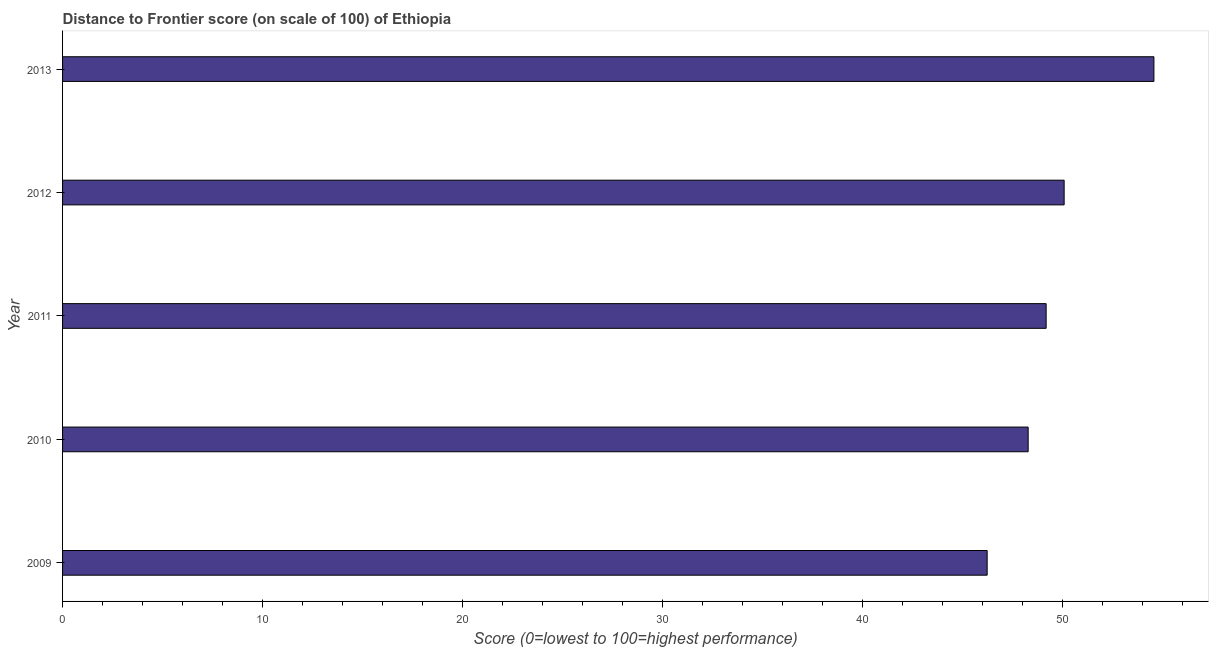Does the graph contain any zero values?
Provide a succinct answer. No. What is the title of the graph?
Your answer should be very brief. Distance to Frontier score (on scale of 100) of Ethiopia. What is the label or title of the X-axis?
Make the answer very short. Score (0=lowest to 100=highest performance). What is the label or title of the Y-axis?
Provide a succinct answer. Year. What is the distance to frontier score in 2012?
Provide a succinct answer. 50.09. Across all years, what is the maximum distance to frontier score?
Your response must be concise. 54.58. Across all years, what is the minimum distance to frontier score?
Ensure brevity in your answer.  46.24. What is the sum of the distance to frontier score?
Keep it short and to the point. 248.39. What is the difference between the distance to frontier score in 2009 and 2012?
Make the answer very short. -3.85. What is the average distance to frontier score per year?
Your answer should be very brief. 49.68. What is the median distance to frontier score?
Your response must be concise. 49.19. What is the ratio of the distance to frontier score in 2011 to that in 2013?
Your answer should be compact. 0.9. Is the difference between the distance to frontier score in 2010 and 2012 greater than the difference between any two years?
Your answer should be very brief. No. What is the difference between the highest and the second highest distance to frontier score?
Your answer should be very brief. 4.49. What is the difference between the highest and the lowest distance to frontier score?
Ensure brevity in your answer.  8.34. In how many years, is the distance to frontier score greater than the average distance to frontier score taken over all years?
Keep it short and to the point. 2. How many bars are there?
Offer a terse response. 5. Are the values on the major ticks of X-axis written in scientific E-notation?
Your answer should be very brief. No. What is the Score (0=lowest to 100=highest performance) of 2009?
Your answer should be very brief. 46.24. What is the Score (0=lowest to 100=highest performance) of 2010?
Offer a terse response. 48.29. What is the Score (0=lowest to 100=highest performance) in 2011?
Offer a terse response. 49.19. What is the Score (0=lowest to 100=highest performance) of 2012?
Provide a succinct answer. 50.09. What is the Score (0=lowest to 100=highest performance) in 2013?
Offer a very short reply. 54.58. What is the difference between the Score (0=lowest to 100=highest performance) in 2009 and 2010?
Provide a short and direct response. -2.05. What is the difference between the Score (0=lowest to 100=highest performance) in 2009 and 2011?
Offer a very short reply. -2.95. What is the difference between the Score (0=lowest to 100=highest performance) in 2009 and 2012?
Your response must be concise. -3.85. What is the difference between the Score (0=lowest to 100=highest performance) in 2009 and 2013?
Give a very brief answer. -8.34. What is the difference between the Score (0=lowest to 100=highest performance) in 2010 and 2011?
Your response must be concise. -0.9. What is the difference between the Score (0=lowest to 100=highest performance) in 2010 and 2012?
Your response must be concise. -1.8. What is the difference between the Score (0=lowest to 100=highest performance) in 2010 and 2013?
Your answer should be very brief. -6.29. What is the difference between the Score (0=lowest to 100=highest performance) in 2011 and 2013?
Make the answer very short. -5.39. What is the difference between the Score (0=lowest to 100=highest performance) in 2012 and 2013?
Ensure brevity in your answer.  -4.49. What is the ratio of the Score (0=lowest to 100=highest performance) in 2009 to that in 2010?
Your response must be concise. 0.96. What is the ratio of the Score (0=lowest to 100=highest performance) in 2009 to that in 2012?
Your response must be concise. 0.92. What is the ratio of the Score (0=lowest to 100=highest performance) in 2009 to that in 2013?
Ensure brevity in your answer.  0.85. What is the ratio of the Score (0=lowest to 100=highest performance) in 2010 to that in 2013?
Your response must be concise. 0.89. What is the ratio of the Score (0=lowest to 100=highest performance) in 2011 to that in 2013?
Provide a short and direct response. 0.9. What is the ratio of the Score (0=lowest to 100=highest performance) in 2012 to that in 2013?
Your answer should be compact. 0.92. 